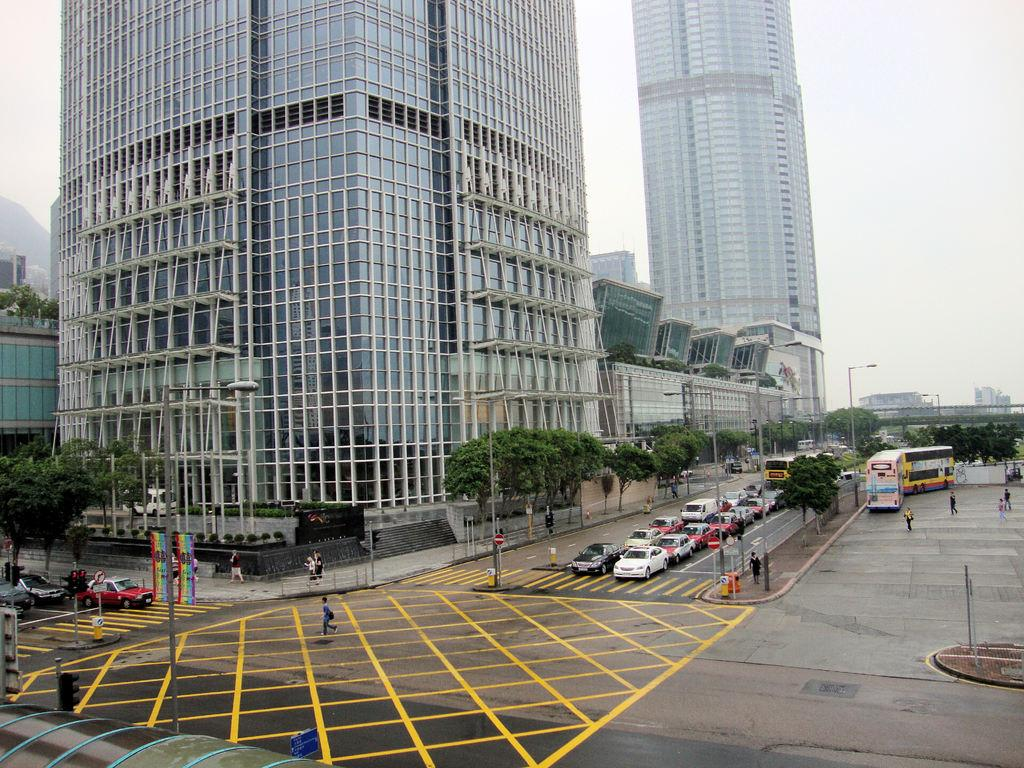What is happening on the board in the image? There are vehicles moving on the board in the image. What type of natural elements can be seen in the image? There are trees visible in the image. What type of man-made structures are present in the image? There are buildings in the image. What are the people in the image doing? People are walking on the road in the image. What type of canvas is being used to create the image? The image is not a painting or artwork, so there is no canvas involved in its creation. 